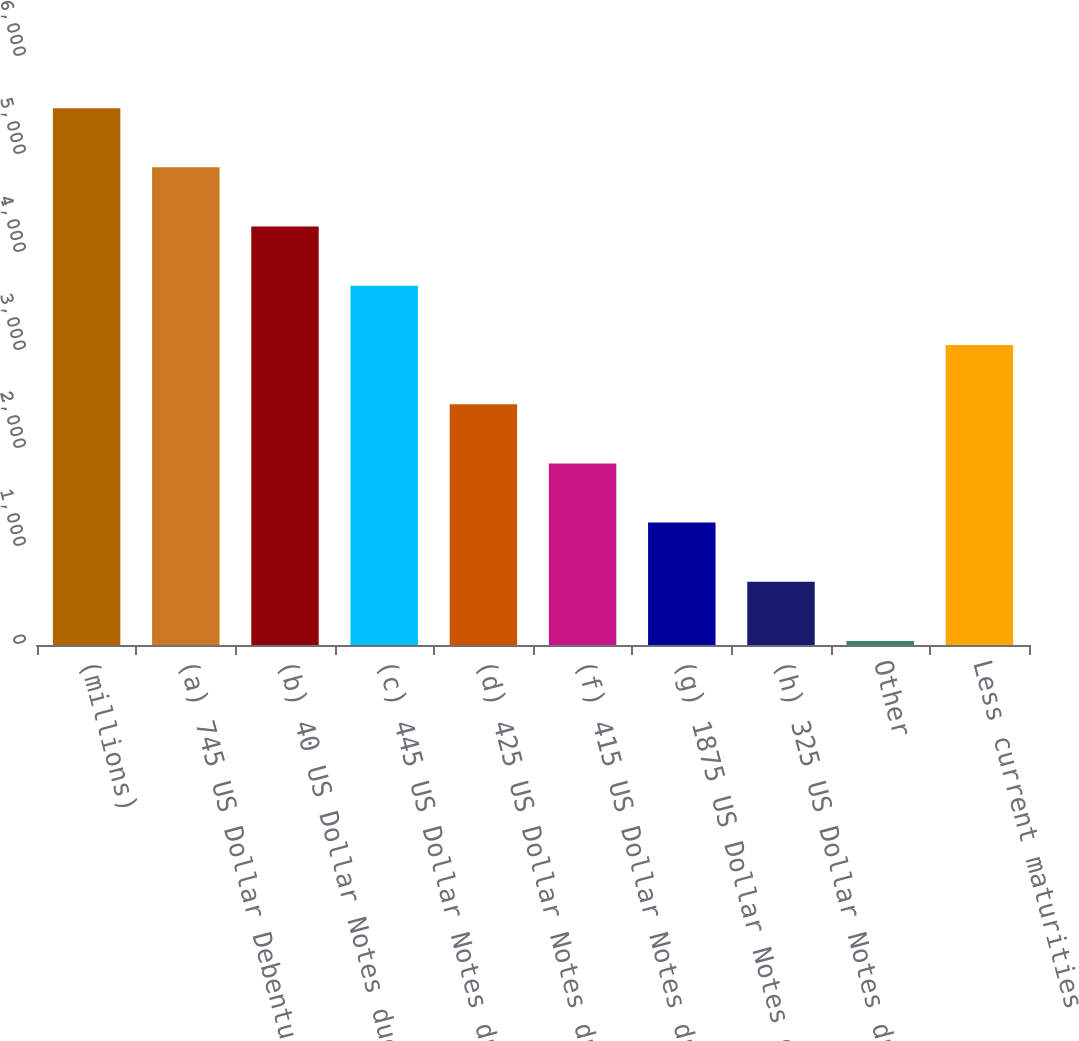Convert chart to OTSL. <chart><loc_0><loc_0><loc_500><loc_500><bar_chart><fcel>(millions)<fcel>(a) 745 US Dollar Debentures<fcel>(b) 40 US Dollar Notes due<fcel>(c) 445 US Dollar Notes due<fcel>(d) 425 US Dollar Notes due<fcel>(f) 415 US Dollar Notes due<fcel>(g) 1875 US Dollar Notes due<fcel>(h) 325 US Dollar Notes due<fcel>Other<fcel>Less current maturities<nl><fcel>5477.9<fcel>4873.8<fcel>4269.7<fcel>3665.6<fcel>2457.4<fcel>1853.3<fcel>1249.2<fcel>645.1<fcel>41<fcel>3061.5<nl></chart> 